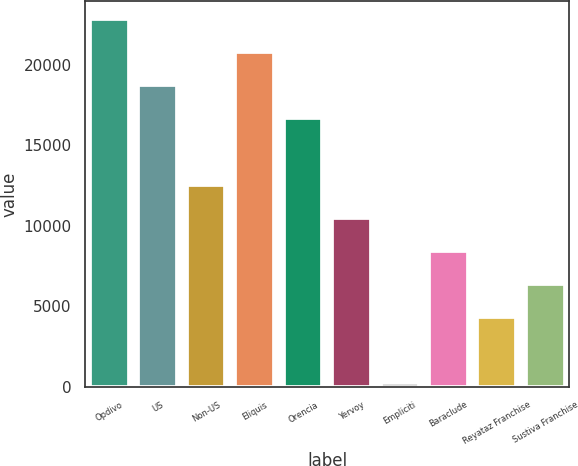Convert chart to OTSL. <chart><loc_0><loc_0><loc_500><loc_500><bar_chart><fcel>Opdivo<fcel>US<fcel>Non-US<fcel>Eliquis<fcel>Orencia<fcel>Yervoy<fcel>Empliciti<fcel>Baraclude<fcel>Reyataz Franchise<fcel>Sustiva Franchise<nl><fcel>22830.5<fcel>18721.5<fcel>12558<fcel>20776<fcel>16667<fcel>10503.5<fcel>231<fcel>8449<fcel>4340<fcel>6394.5<nl></chart> 